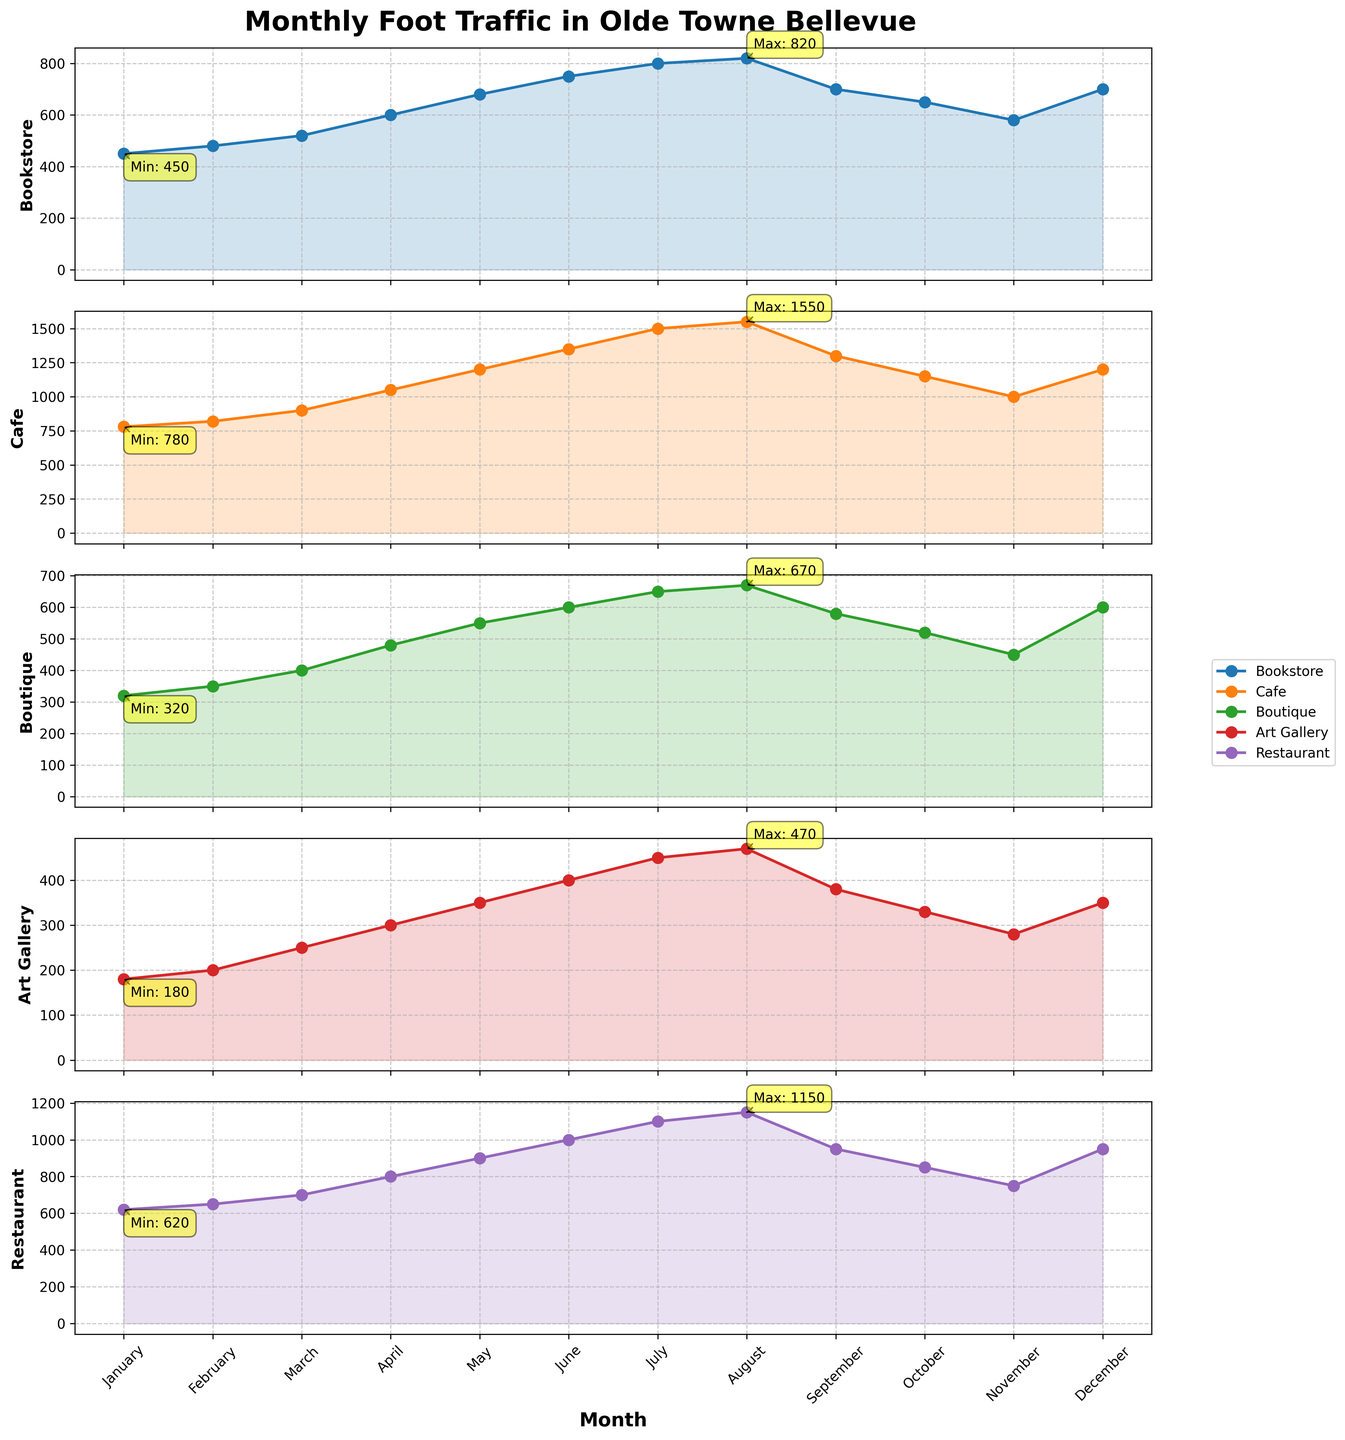What's the title of the figure? The title of the figure is displayed at the top, in bold font. It reads "Monthly Foot Traffic in Olde Towne Bellevue."
Answer: Monthly Foot Traffic in Olde Towne Bellevue Which business has the highest foot traffic in December? To determine this, we check the data point under December for each subplot or the y-axis labels for December values and find the highest one. The Restaurant has the highest foot traffic with 950 visitors.
Answer: Restaurant In which month did the Cafe have its highest foot traffic? Look at the subplot for Cafe and identify the month where the data point reaches its peak. The annotation may help, too. The highest foot traffic for the Cafe is in August.
Answer: August What is the overall trend in foot traffic for the Bookstore from January to December? Examine the subplot for the Bookstore from left to right (January to December). Foot traffic generally increases from January to August, dips in September and October, and rises again in December.
Answer: Increase, dip, rise How does the foot traffic for the Boutique in May compare to that in October? Refer to the subplot for the Boutique and compare the y-axis values for May and October. In May, the foot traffic is 550, whereas in October, it's 520.
Answer: Higher in May Which month shows the lowest foot traffic for the Art Gallery? Look at the subplot for Art Gallery and find the month corresponding to the lowest data point, which is January.
Answer: January Calculate the average foot traffic for the Bookstore over the year. Add the monthly foot traffic for the Bookstore and divide by 12 (total months). (450 + 480 + 520 + 600 + 680 + 750 + 800 + 820 + 700 + 650 + 580 + 700) / 12 = 686.67
Answer: 686.67 Is there a month where the foot traffic for all businesses increases compared to the previous month? We compare each month to the previous one for all subplots. The only month where all businesses show an increase is March (compared to February).
Answer: March What is the difference in foot traffic between the highest and lowest month for the Cafe? The subplot for Cafe shows the highest foot traffic in August (1550) and the lowest in January (780). The difference is 1550 - 780 = 770.
Answer: 770 Which business experienced a decline in foot traffic from June to July? Go through each subplot and compare June and July values. The Art Gallery shows a decline from 400 in June to 450 in July.
Answer: Art Gallery 